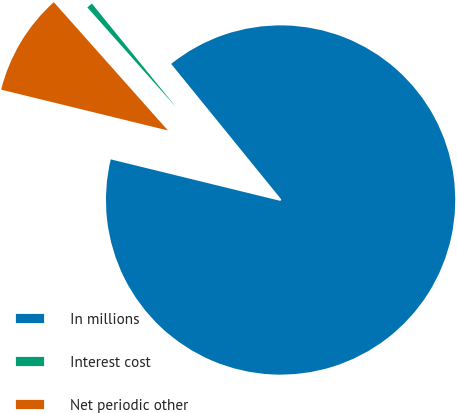Convert chart to OTSL. <chart><loc_0><loc_0><loc_500><loc_500><pie_chart><fcel>In millions<fcel>Interest cost<fcel>Net periodic other<nl><fcel>89.68%<fcel>0.71%<fcel>9.61%<nl></chart> 